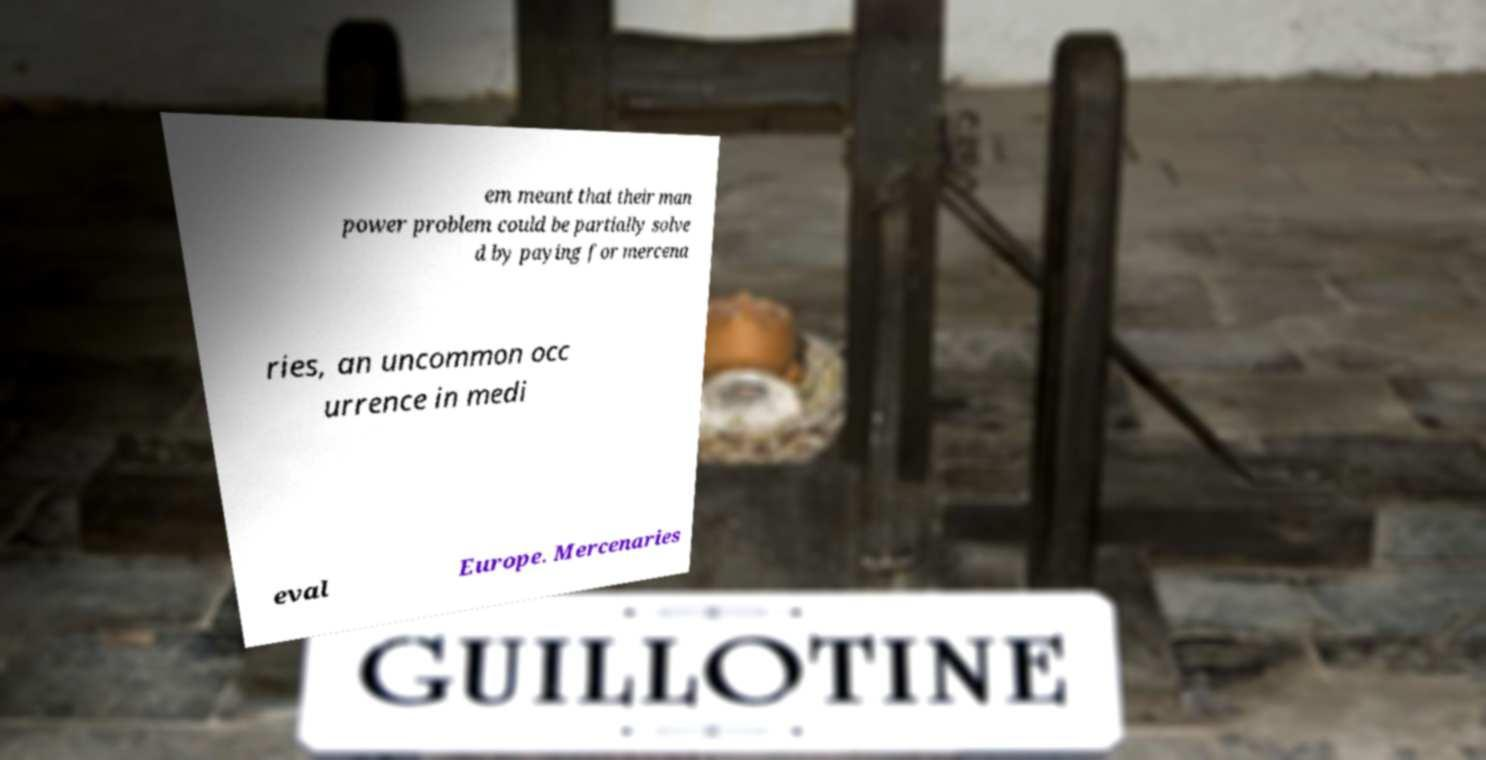Please read and relay the text visible in this image. What does it say? em meant that their man power problem could be partially solve d by paying for mercena ries, an uncommon occ urrence in medi eval Europe. Mercenaries 